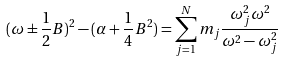<formula> <loc_0><loc_0><loc_500><loc_500>( \omega \pm \frac { 1 } { 2 } B ) ^ { 2 } - ( \alpha + \frac { 1 } { 4 } B ^ { 2 } ) = \sum _ { j = 1 } ^ { N } m _ { j } \frac { \omega _ { j } ^ { 2 } \omega ^ { 2 } } { \omega ^ { 2 } - \omega _ { j } ^ { 2 } }</formula> 